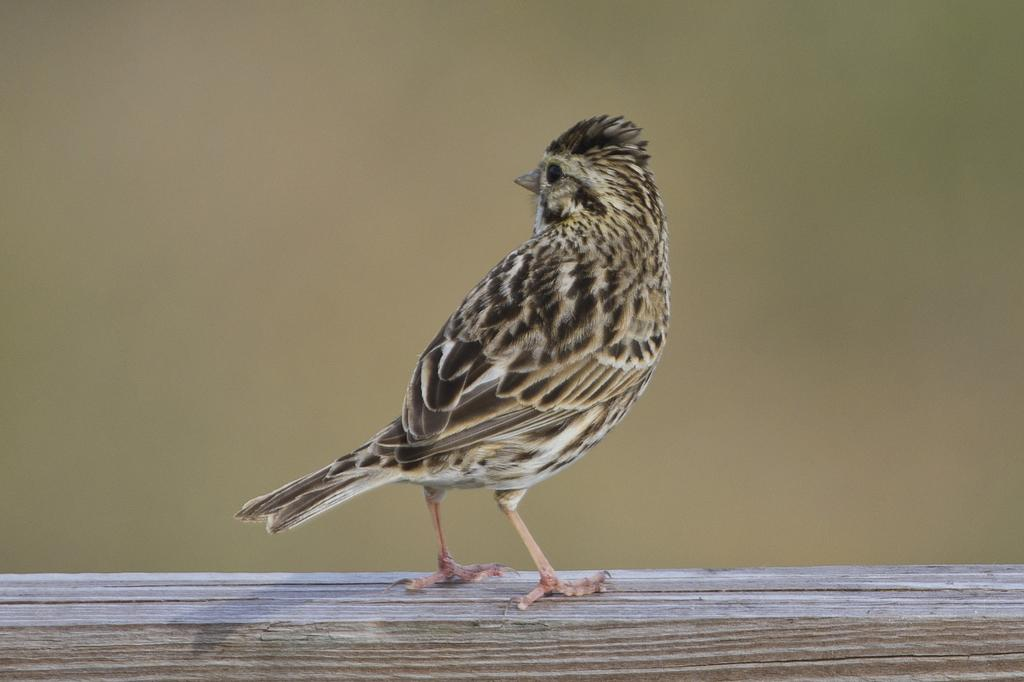What is the main subject of the image? There is a bird in the center of the image. Can you describe the background of the image? The background of the image is blurry. Where is the office located in the image? There is no office present in the image; it features a bird in the center. What type of stick can be seen in the bird's beak in the image? There is no stick present in the image; the bird does not have anything in its beak. 